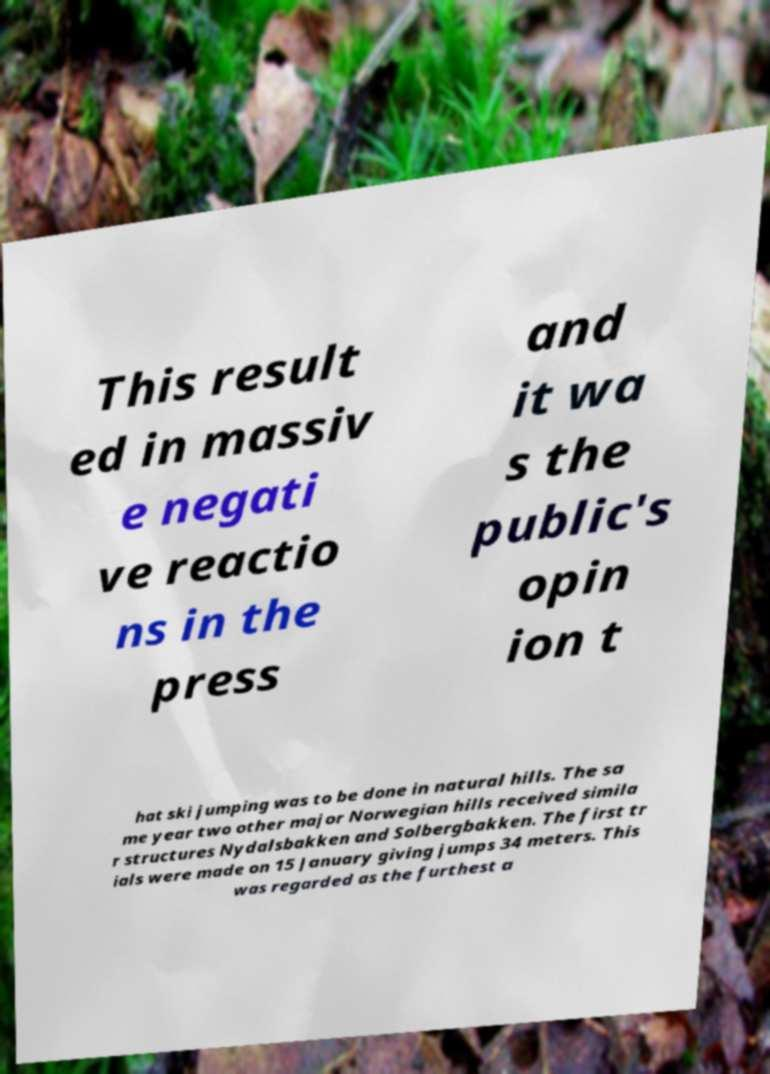What messages or text are displayed in this image? I need them in a readable, typed format. This result ed in massiv e negati ve reactio ns in the press and it wa s the public's opin ion t hat ski jumping was to be done in natural hills. The sa me year two other major Norwegian hills received simila r structures Nydalsbakken and Solbergbakken. The first tr ials were made on 15 January giving jumps 34 meters. This was regarded as the furthest a 